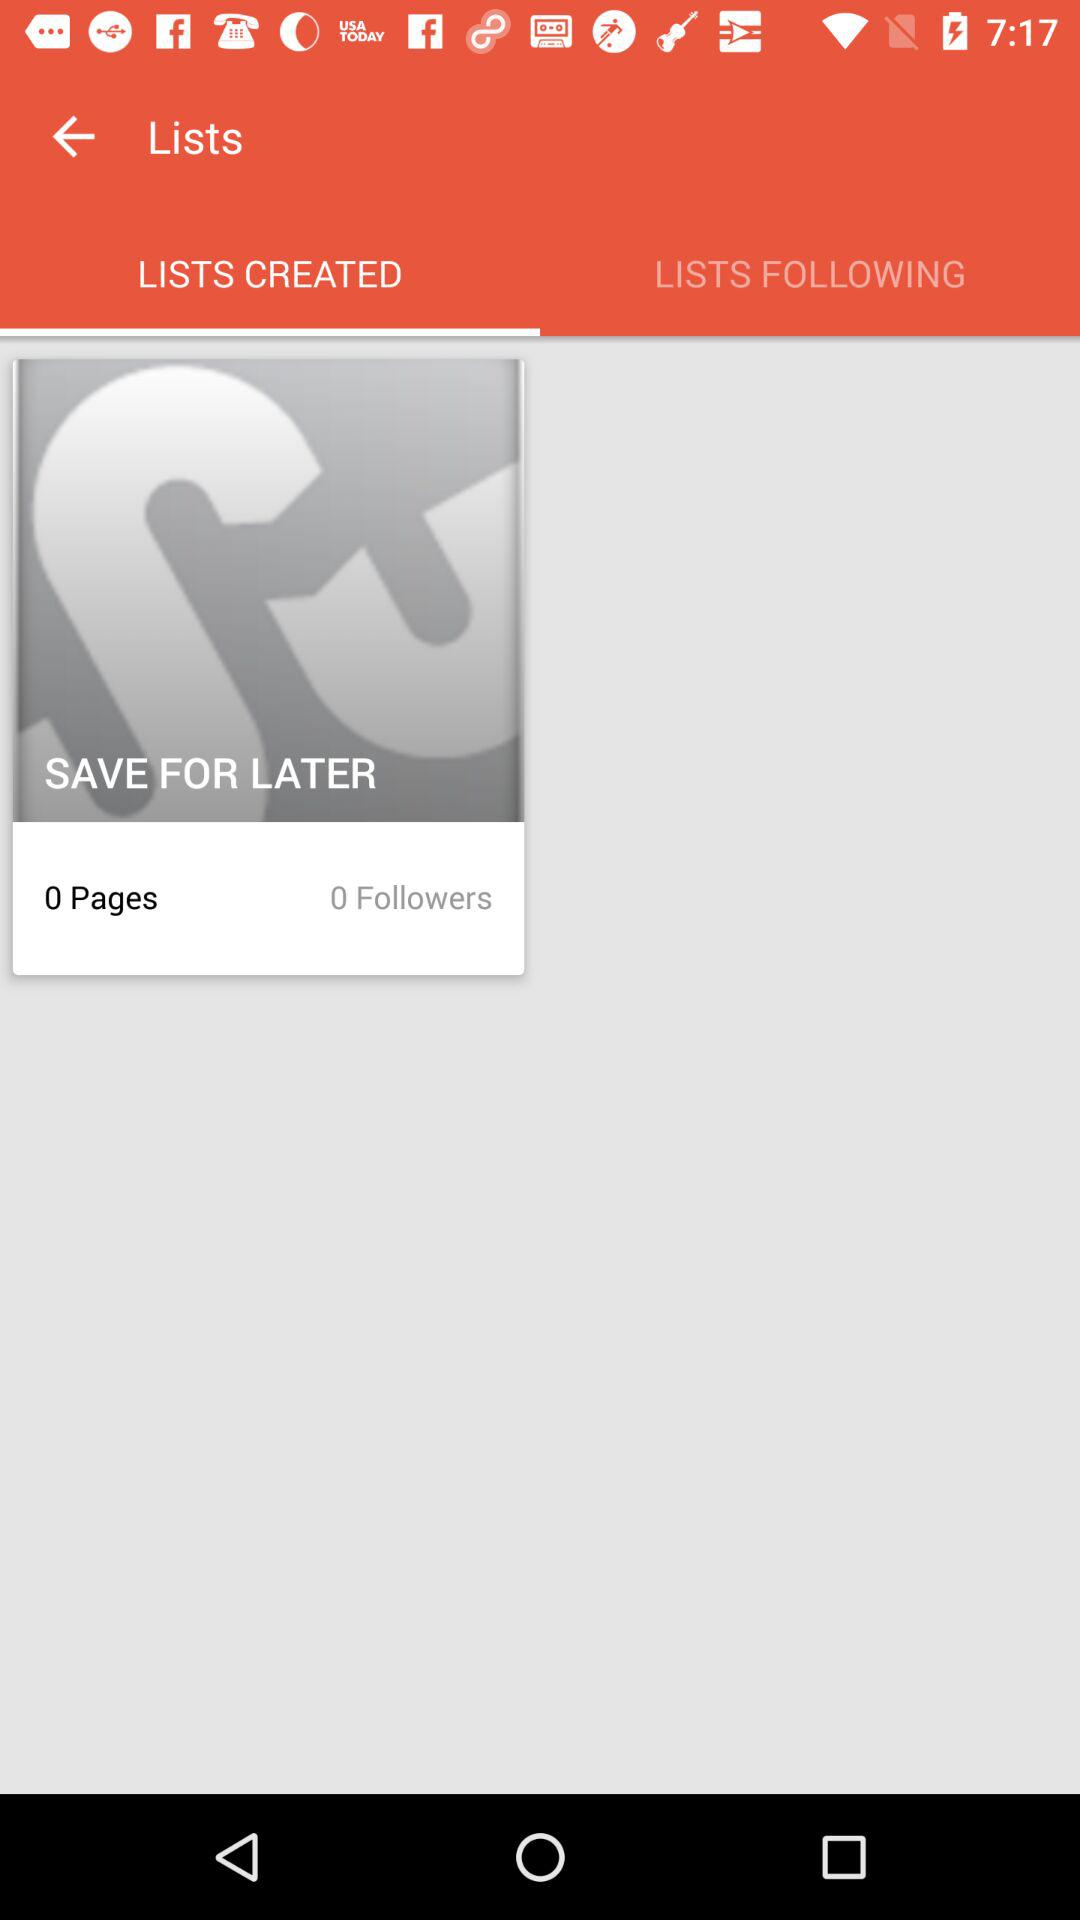How many pages are in "SAVE FOR LATER" folder? There are 0 pages. 